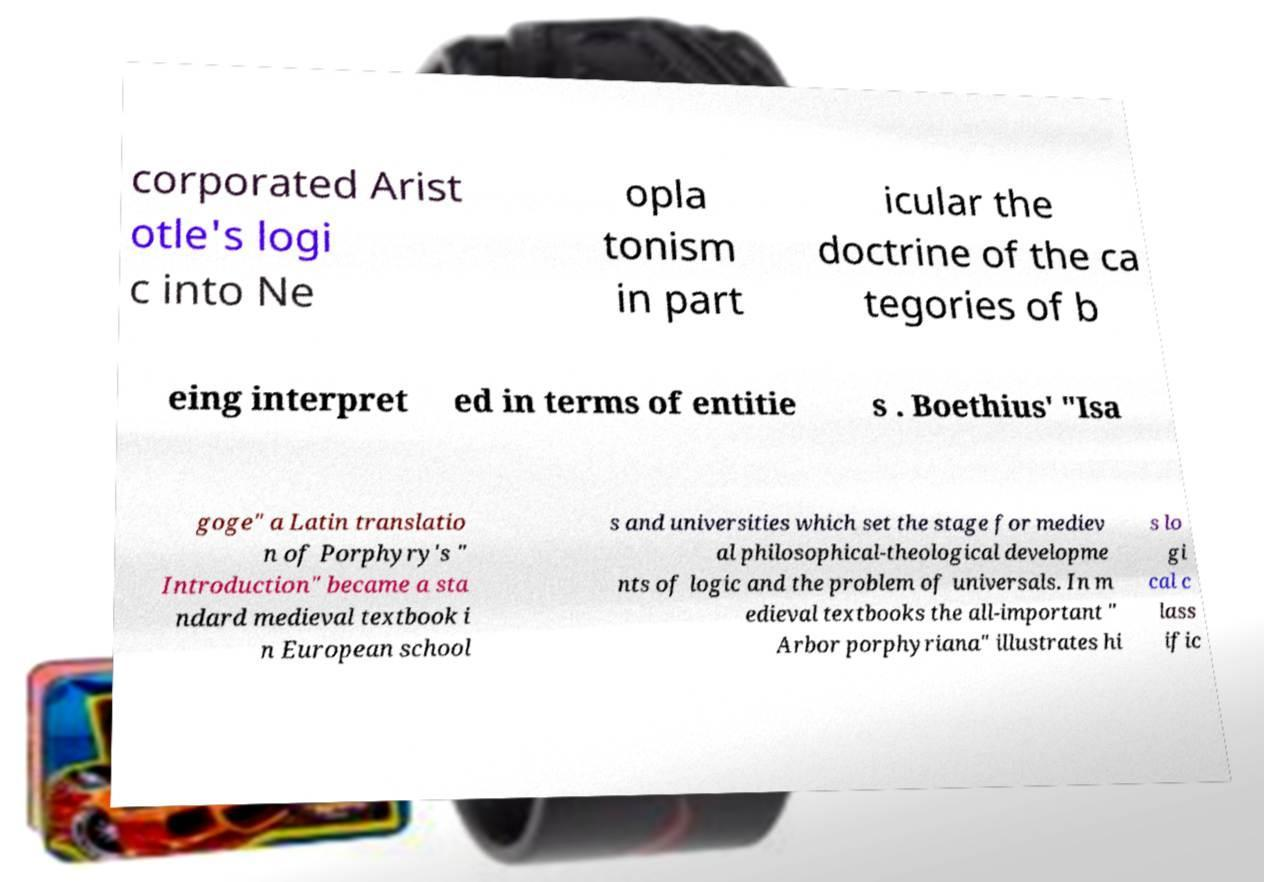Can you accurately transcribe the text from the provided image for me? corporated Arist otle's logi c into Ne opla tonism in part icular the doctrine of the ca tegories of b eing interpret ed in terms of entitie s . Boethius' "Isa goge" a Latin translatio n of Porphyry's " Introduction" became a sta ndard medieval textbook i n European school s and universities which set the stage for mediev al philosophical-theological developme nts of logic and the problem of universals. In m edieval textbooks the all-important " Arbor porphyriana" illustrates hi s lo gi cal c lass ific 